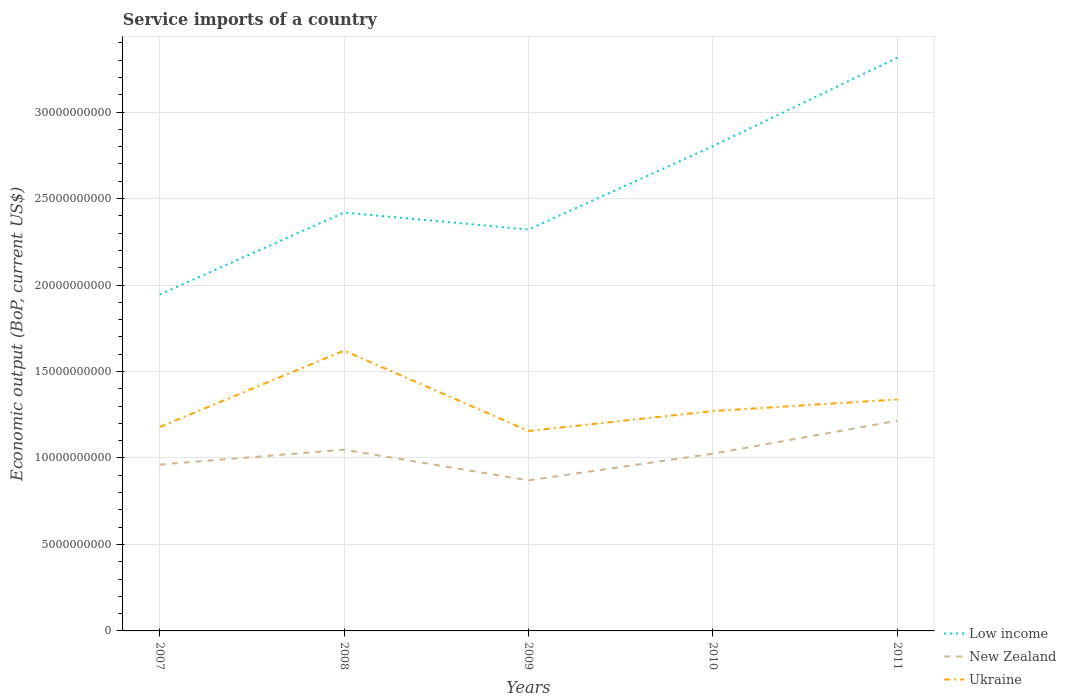Is the number of lines equal to the number of legend labels?
Your answer should be very brief. Yes. Across all years, what is the maximum service imports in Ukraine?
Provide a succinct answer. 1.16e+1. What is the total service imports in Ukraine in the graph?
Your answer should be compact. -6.71e+08. What is the difference between the highest and the second highest service imports in Ukraine?
Provide a short and direct response. 4.65e+09. What is the difference between the highest and the lowest service imports in Ukraine?
Keep it short and to the point. 2. Does the graph contain grids?
Provide a succinct answer. Yes. Where does the legend appear in the graph?
Your answer should be very brief. Bottom right. How many legend labels are there?
Your response must be concise. 3. How are the legend labels stacked?
Provide a short and direct response. Vertical. What is the title of the graph?
Your answer should be very brief. Service imports of a country. What is the label or title of the X-axis?
Give a very brief answer. Years. What is the label or title of the Y-axis?
Offer a very short reply. Economic output (BoP, current US$). What is the Economic output (BoP, current US$) in Low income in 2007?
Offer a very short reply. 1.94e+1. What is the Economic output (BoP, current US$) in New Zealand in 2007?
Make the answer very short. 9.62e+09. What is the Economic output (BoP, current US$) of Ukraine in 2007?
Offer a terse response. 1.18e+1. What is the Economic output (BoP, current US$) in Low income in 2008?
Keep it short and to the point. 2.42e+1. What is the Economic output (BoP, current US$) of New Zealand in 2008?
Your answer should be very brief. 1.05e+1. What is the Economic output (BoP, current US$) in Ukraine in 2008?
Give a very brief answer. 1.62e+1. What is the Economic output (BoP, current US$) in Low income in 2009?
Your answer should be very brief. 2.32e+1. What is the Economic output (BoP, current US$) of New Zealand in 2009?
Your response must be concise. 8.71e+09. What is the Economic output (BoP, current US$) of Ukraine in 2009?
Provide a succinct answer. 1.16e+1. What is the Economic output (BoP, current US$) of Low income in 2010?
Ensure brevity in your answer.  2.80e+1. What is the Economic output (BoP, current US$) of New Zealand in 2010?
Your answer should be compact. 1.02e+1. What is the Economic output (BoP, current US$) of Ukraine in 2010?
Offer a terse response. 1.27e+1. What is the Economic output (BoP, current US$) in Low income in 2011?
Keep it short and to the point. 3.31e+1. What is the Economic output (BoP, current US$) of New Zealand in 2011?
Provide a short and direct response. 1.22e+1. What is the Economic output (BoP, current US$) in Ukraine in 2011?
Make the answer very short. 1.34e+1. Across all years, what is the maximum Economic output (BoP, current US$) of Low income?
Your answer should be very brief. 3.31e+1. Across all years, what is the maximum Economic output (BoP, current US$) in New Zealand?
Ensure brevity in your answer.  1.22e+1. Across all years, what is the maximum Economic output (BoP, current US$) of Ukraine?
Your answer should be very brief. 1.62e+1. Across all years, what is the minimum Economic output (BoP, current US$) of Low income?
Give a very brief answer. 1.94e+1. Across all years, what is the minimum Economic output (BoP, current US$) in New Zealand?
Make the answer very short. 8.71e+09. Across all years, what is the minimum Economic output (BoP, current US$) in Ukraine?
Your response must be concise. 1.16e+1. What is the total Economic output (BoP, current US$) of Low income in the graph?
Make the answer very short. 1.28e+11. What is the total Economic output (BoP, current US$) in New Zealand in the graph?
Your answer should be compact. 5.12e+1. What is the total Economic output (BoP, current US$) in Ukraine in the graph?
Make the answer very short. 6.57e+1. What is the difference between the Economic output (BoP, current US$) of Low income in 2007 and that in 2008?
Offer a terse response. -4.74e+09. What is the difference between the Economic output (BoP, current US$) of New Zealand in 2007 and that in 2008?
Give a very brief answer. -8.61e+08. What is the difference between the Economic output (BoP, current US$) of Ukraine in 2007 and that in 2008?
Make the answer very short. -4.42e+09. What is the difference between the Economic output (BoP, current US$) of Low income in 2007 and that in 2009?
Give a very brief answer. -3.76e+09. What is the difference between the Economic output (BoP, current US$) in New Zealand in 2007 and that in 2009?
Your answer should be very brief. 9.11e+08. What is the difference between the Economic output (BoP, current US$) of Ukraine in 2007 and that in 2009?
Provide a short and direct response. 2.30e+08. What is the difference between the Economic output (BoP, current US$) of Low income in 2007 and that in 2010?
Ensure brevity in your answer.  -8.58e+09. What is the difference between the Economic output (BoP, current US$) in New Zealand in 2007 and that in 2010?
Provide a succinct answer. -6.31e+08. What is the difference between the Economic output (BoP, current US$) of Ukraine in 2007 and that in 2010?
Provide a succinct answer. -9.22e+08. What is the difference between the Economic output (BoP, current US$) in Low income in 2007 and that in 2011?
Your answer should be very brief. -1.37e+1. What is the difference between the Economic output (BoP, current US$) in New Zealand in 2007 and that in 2011?
Offer a terse response. -2.53e+09. What is the difference between the Economic output (BoP, current US$) of Ukraine in 2007 and that in 2011?
Offer a terse response. -1.59e+09. What is the difference between the Economic output (BoP, current US$) of Low income in 2008 and that in 2009?
Provide a short and direct response. 9.83e+08. What is the difference between the Economic output (BoP, current US$) of New Zealand in 2008 and that in 2009?
Your response must be concise. 1.77e+09. What is the difference between the Economic output (BoP, current US$) of Ukraine in 2008 and that in 2009?
Provide a short and direct response. 4.65e+09. What is the difference between the Economic output (BoP, current US$) of Low income in 2008 and that in 2010?
Offer a terse response. -3.83e+09. What is the difference between the Economic output (BoP, current US$) in New Zealand in 2008 and that in 2010?
Give a very brief answer. 2.30e+08. What is the difference between the Economic output (BoP, current US$) of Ukraine in 2008 and that in 2010?
Your answer should be very brief. 3.50e+09. What is the difference between the Economic output (BoP, current US$) in Low income in 2008 and that in 2011?
Provide a succinct answer. -8.95e+09. What is the difference between the Economic output (BoP, current US$) of New Zealand in 2008 and that in 2011?
Your response must be concise. -1.67e+09. What is the difference between the Economic output (BoP, current US$) in Ukraine in 2008 and that in 2011?
Keep it short and to the point. 2.82e+09. What is the difference between the Economic output (BoP, current US$) of Low income in 2009 and that in 2010?
Offer a terse response. -4.82e+09. What is the difference between the Economic output (BoP, current US$) in New Zealand in 2009 and that in 2010?
Offer a very short reply. -1.54e+09. What is the difference between the Economic output (BoP, current US$) of Ukraine in 2009 and that in 2010?
Offer a terse response. -1.15e+09. What is the difference between the Economic output (BoP, current US$) of Low income in 2009 and that in 2011?
Provide a short and direct response. -9.93e+09. What is the difference between the Economic output (BoP, current US$) of New Zealand in 2009 and that in 2011?
Your answer should be compact. -3.44e+09. What is the difference between the Economic output (BoP, current US$) of Ukraine in 2009 and that in 2011?
Give a very brief answer. -1.82e+09. What is the difference between the Economic output (BoP, current US$) in Low income in 2010 and that in 2011?
Give a very brief answer. -5.12e+09. What is the difference between the Economic output (BoP, current US$) in New Zealand in 2010 and that in 2011?
Keep it short and to the point. -1.90e+09. What is the difference between the Economic output (BoP, current US$) in Ukraine in 2010 and that in 2011?
Offer a terse response. -6.71e+08. What is the difference between the Economic output (BoP, current US$) of Low income in 2007 and the Economic output (BoP, current US$) of New Zealand in 2008?
Keep it short and to the point. 8.97e+09. What is the difference between the Economic output (BoP, current US$) in Low income in 2007 and the Economic output (BoP, current US$) in Ukraine in 2008?
Provide a short and direct response. 3.24e+09. What is the difference between the Economic output (BoP, current US$) in New Zealand in 2007 and the Economic output (BoP, current US$) in Ukraine in 2008?
Provide a short and direct response. -6.59e+09. What is the difference between the Economic output (BoP, current US$) in Low income in 2007 and the Economic output (BoP, current US$) in New Zealand in 2009?
Give a very brief answer. 1.07e+1. What is the difference between the Economic output (BoP, current US$) in Low income in 2007 and the Economic output (BoP, current US$) in Ukraine in 2009?
Make the answer very short. 7.89e+09. What is the difference between the Economic output (BoP, current US$) of New Zealand in 2007 and the Economic output (BoP, current US$) of Ukraine in 2009?
Your response must be concise. -1.94e+09. What is the difference between the Economic output (BoP, current US$) of Low income in 2007 and the Economic output (BoP, current US$) of New Zealand in 2010?
Your response must be concise. 9.20e+09. What is the difference between the Economic output (BoP, current US$) of Low income in 2007 and the Economic output (BoP, current US$) of Ukraine in 2010?
Offer a terse response. 6.74e+09. What is the difference between the Economic output (BoP, current US$) of New Zealand in 2007 and the Economic output (BoP, current US$) of Ukraine in 2010?
Your answer should be compact. -3.09e+09. What is the difference between the Economic output (BoP, current US$) in Low income in 2007 and the Economic output (BoP, current US$) in New Zealand in 2011?
Your response must be concise. 7.30e+09. What is the difference between the Economic output (BoP, current US$) in Low income in 2007 and the Economic output (BoP, current US$) in Ukraine in 2011?
Ensure brevity in your answer.  6.07e+09. What is the difference between the Economic output (BoP, current US$) in New Zealand in 2007 and the Economic output (BoP, current US$) in Ukraine in 2011?
Your answer should be compact. -3.77e+09. What is the difference between the Economic output (BoP, current US$) in Low income in 2008 and the Economic output (BoP, current US$) in New Zealand in 2009?
Ensure brevity in your answer.  1.55e+1. What is the difference between the Economic output (BoP, current US$) in Low income in 2008 and the Economic output (BoP, current US$) in Ukraine in 2009?
Offer a very short reply. 1.26e+1. What is the difference between the Economic output (BoP, current US$) in New Zealand in 2008 and the Economic output (BoP, current US$) in Ukraine in 2009?
Your answer should be very brief. -1.08e+09. What is the difference between the Economic output (BoP, current US$) of Low income in 2008 and the Economic output (BoP, current US$) of New Zealand in 2010?
Provide a succinct answer. 1.39e+1. What is the difference between the Economic output (BoP, current US$) in Low income in 2008 and the Economic output (BoP, current US$) in Ukraine in 2010?
Your answer should be very brief. 1.15e+1. What is the difference between the Economic output (BoP, current US$) of New Zealand in 2008 and the Economic output (BoP, current US$) of Ukraine in 2010?
Ensure brevity in your answer.  -2.23e+09. What is the difference between the Economic output (BoP, current US$) in Low income in 2008 and the Economic output (BoP, current US$) in New Zealand in 2011?
Keep it short and to the point. 1.20e+1. What is the difference between the Economic output (BoP, current US$) in Low income in 2008 and the Economic output (BoP, current US$) in Ukraine in 2011?
Your response must be concise. 1.08e+1. What is the difference between the Economic output (BoP, current US$) of New Zealand in 2008 and the Economic output (BoP, current US$) of Ukraine in 2011?
Make the answer very short. -2.91e+09. What is the difference between the Economic output (BoP, current US$) in Low income in 2009 and the Economic output (BoP, current US$) in New Zealand in 2010?
Provide a short and direct response. 1.30e+1. What is the difference between the Economic output (BoP, current US$) in Low income in 2009 and the Economic output (BoP, current US$) in Ukraine in 2010?
Provide a short and direct response. 1.05e+1. What is the difference between the Economic output (BoP, current US$) in New Zealand in 2009 and the Economic output (BoP, current US$) in Ukraine in 2010?
Make the answer very short. -4.01e+09. What is the difference between the Economic output (BoP, current US$) in Low income in 2009 and the Economic output (BoP, current US$) in New Zealand in 2011?
Your answer should be compact. 1.11e+1. What is the difference between the Economic output (BoP, current US$) of Low income in 2009 and the Economic output (BoP, current US$) of Ukraine in 2011?
Provide a succinct answer. 9.82e+09. What is the difference between the Economic output (BoP, current US$) of New Zealand in 2009 and the Economic output (BoP, current US$) of Ukraine in 2011?
Your response must be concise. -4.68e+09. What is the difference between the Economic output (BoP, current US$) of Low income in 2010 and the Economic output (BoP, current US$) of New Zealand in 2011?
Your answer should be compact. 1.59e+1. What is the difference between the Economic output (BoP, current US$) of Low income in 2010 and the Economic output (BoP, current US$) of Ukraine in 2011?
Your response must be concise. 1.46e+1. What is the difference between the Economic output (BoP, current US$) in New Zealand in 2010 and the Economic output (BoP, current US$) in Ukraine in 2011?
Your answer should be very brief. -3.14e+09. What is the average Economic output (BoP, current US$) of Low income per year?
Ensure brevity in your answer.  2.56e+1. What is the average Economic output (BoP, current US$) of New Zealand per year?
Offer a very short reply. 1.02e+1. What is the average Economic output (BoP, current US$) in Ukraine per year?
Provide a succinct answer. 1.31e+1. In the year 2007, what is the difference between the Economic output (BoP, current US$) of Low income and Economic output (BoP, current US$) of New Zealand?
Ensure brevity in your answer.  9.83e+09. In the year 2007, what is the difference between the Economic output (BoP, current US$) in Low income and Economic output (BoP, current US$) in Ukraine?
Your response must be concise. 7.66e+09. In the year 2007, what is the difference between the Economic output (BoP, current US$) of New Zealand and Economic output (BoP, current US$) of Ukraine?
Make the answer very short. -2.17e+09. In the year 2008, what is the difference between the Economic output (BoP, current US$) of Low income and Economic output (BoP, current US$) of New Zealand?
Provide a succinct answer. 1.37e+1. In the year 2008, what is the difference between the Economic output (BoP, current US$) of Low income and Economic output (BoP, current US$) of Ukraine?
Keep it short and to the point. 7.98e+09. In the year 2008, what is the difference between the Economic output (BoP, current US$) in New Zealand and Economic output (BoP, current US$) in Ukraine?
Keep it short and to the point. -5.73e+09. In the year 2009, what is the difference between the Economic output (BoP, current US$) in Low income and Economic output (BoP, current US$) in New Zealand?
Keep it short and to the point. 1.45e+1. In the year 2009, what is the difference between the Economic output (BoP, current US$) of Low income and Economic output (BoP, current US$) of Ukraine?
Provide a short and direct response. 1.16e+1. In the year 2009, what is the difference between the Economic output (BoP, current US$) of New Zealand and Economic output (BoP, current US$) of Ukraine?
Offer a terse response. -2.85e+09. In the year 2010, what is the difference between the Economic output (BoP, current US$) in Low income and Economic output (BoP, current US$) in New Zealand?
Give a very brief answer. 1.78e+1. In the year 2010, what is the difference between the Economic output (BoP, current US$) in Low income and Economic output (BoP, current US$) in Ukraine?
Offer a terse response. 1.53e+1. In the year 2010, what is the difference between the Economic output (BoP, current US$) in New Zealand and Economic output (BoP, current US$) in Ukraine?
Offer a very short reply. -2.46e+09. In the year 2011, what is the difference between the Economic output (BoP, current US$) in Low income and Economic output (BoP, current US$) in New Zealand?
Keep it short and to the point. 2.10e+1. In the year 2011, what is the difference between the Economic output (BoP, current US$) of Low income and Economic output (BoP, current US$) of Ukraine?
Provide a succinct answer. 1.98e+1. In the year 2011, what is the difference between the Economic output (BoP, current US$) of New Zealand and Economic output (BoP, current US$) of Ukraine?
Provide a succinct answer. -1.23e+09. What is the ratio of the Economic output (BoP, current US$) in Low income in 2007 to that in 2008?
Keep it short and to the point. 0.8. What is the ratio of the Economic output (BoP, current US$) of New Zealand in 2007 to that in 2008?
Offer a terse response. 0.92. What is the ratio of the Economic output (BoP, current US$) of Ukraine in 2007 to that in 2008?
Ensure brevity in your answer.  0.73. What is the ratio of the Economic output (BoP, current US$) of Low income in 2007 to that in 2009?
Keep it short and to the point. 0.84. What is the ratio of the Economic output (BoP, current US$) of New Zealand in 2007 to that in 2009?
Offer a very short reply. 1.1. What is the ratio of the Economic output (BoP, current US$) of Ukraine in 2007 to that in 2009?
Provide a succinct answer. 1.02. What is the ratio of the Economic output (BoP, current US$) of Low income in 2007 to that in 2010?
Give a very brief answer. 0.69. What is the ratio of the Economic output (BoP, current US$) of New Zealand in 2007 to that in 2010?
Give a very brief answer. 0.94. What is the ratio of the Economic output (BoP, current US$) in Ukraine in 2007 to that in 2010?
Provide a succinct answer. 0.93. What is the ratio of the Economic output (BoP, current US$) of Low income in 2007 to that in 2011?
Offer a terse response. 0.59. What is the ratio of the Economic output (BoP, current US$) of New Zealand in 2007 to that in 2011?
Make the answer very short. 0.79. What is the ratio of the Economic output (BoP, current US$) in Ukraine in 2007 to that in 2011?
Your answer should be compact. 0.88. What is the ratio of the Economic output (BoP, current US$) in Low income in 2008 to that in 2009?
Make the answer very short. 1.04. What is the ratio of the Economic output (BoP, current US$) of New Zealand in 2008 to that in 2009?
Offer a terse response. 1.2. What is the ratio of the Economic output (BoP, current US$) in Ukraine in 2008 to that in 2009?
Give a very brief answer. 1.4. What is the ratio of the Economic output (BoP, current US$) of Low income in 2008 to that in 2010?
Offer a terse response. 0.86. What is the ratio of the Economic output (BoP, current US$) of New Zealand in 2008 to that in 2010?
Offer a very short reply. 1.02. What is the ratio of the Economic output (BoP, current US$) in Ukraine in 2008 to that in 2010?
Make the answer very short. 1.27. What is the ratio of the Economic output (BoP, current US$) of Low income in 2008 to that in 2011?
Keep it short and to the point. 0.73. What is the ratio of the Economic output (BoP, current US$) of New Zealand in 2008 to that in 2011?
Offer a terse response. 0.86. What is the ratio of the Economic output (BoP, current US$) of Ukraine in 2008 to that in 2011?
Your answer should be very brief. 1.21. What is the ratio of the Economic output (BoP, current US$) in Low income in 2009 to that in 2010?
Your answer should be very brief. 0.83. What is the ratio of the Economic output (BoP, current US$) in New Zealand in 2009 to that in 2010?
Make the answer very short. 0.85. What is the ratio of the Economic output (BoP, current US$) in Ukraine in 2009 to that in 2010?
Provide a succinct answer. 0.91. What is the ratio of the Economic output (BoP, current US$) in Low income in 2009 to that in 2011?
Offer a terse response. 0.7. What is the ratio of the Economic output (BoP, current US$) of New Zealand in 2009 to that in 2011?
Provide a succinct answer. 0.72. What is the ratio of the Economic output (BoP, current US$) of Ukraine in 2009 to that in 2011?
Provide a short and direct response. 0.86. What is the ratio of the Economic output (BoP, current US$) in Low income in 2010 to that in 2011?
Give a very brief answer. 0.85. What is the ratio of the Economic output (BoP, current US$) in New Zealand in 2010 to that in 2011?
Give a very brief answer. 0.84. What is the ratio of the Economic output (BoP, current US$) in Ukraine in 2010 to that in 2011?
Keep it short and to the point. 0.95. What is the difference between the highest and the second highest Economic output (BoP, current US$) of Low income?
Keep it short and to the point. 5.12e+09. What is the difference between the highest and the second highest Economic output (BoP, current US$) of New Zealand?
Offer a terse response. 1.67e+09. What is the difference between the highest and the second highest Economic output (BoP, current US$) in Ukraine?
Offer a terse response. 2.82e+09. What is the difference between the highest and the lowest Economic output (BoP, current US$) of Low income?
Your answer should be compact. 1.37e+1. What is the difference between the highest and the lowest Economic output (BoP, current US$) of New Zealand?
Ensure brevity in your answer.  3.44e+09. What is the difference between the highest and the lowest Economic output (BoP, current US$) in Ukraine?
Offer a very short reply. 4.65e+09. 